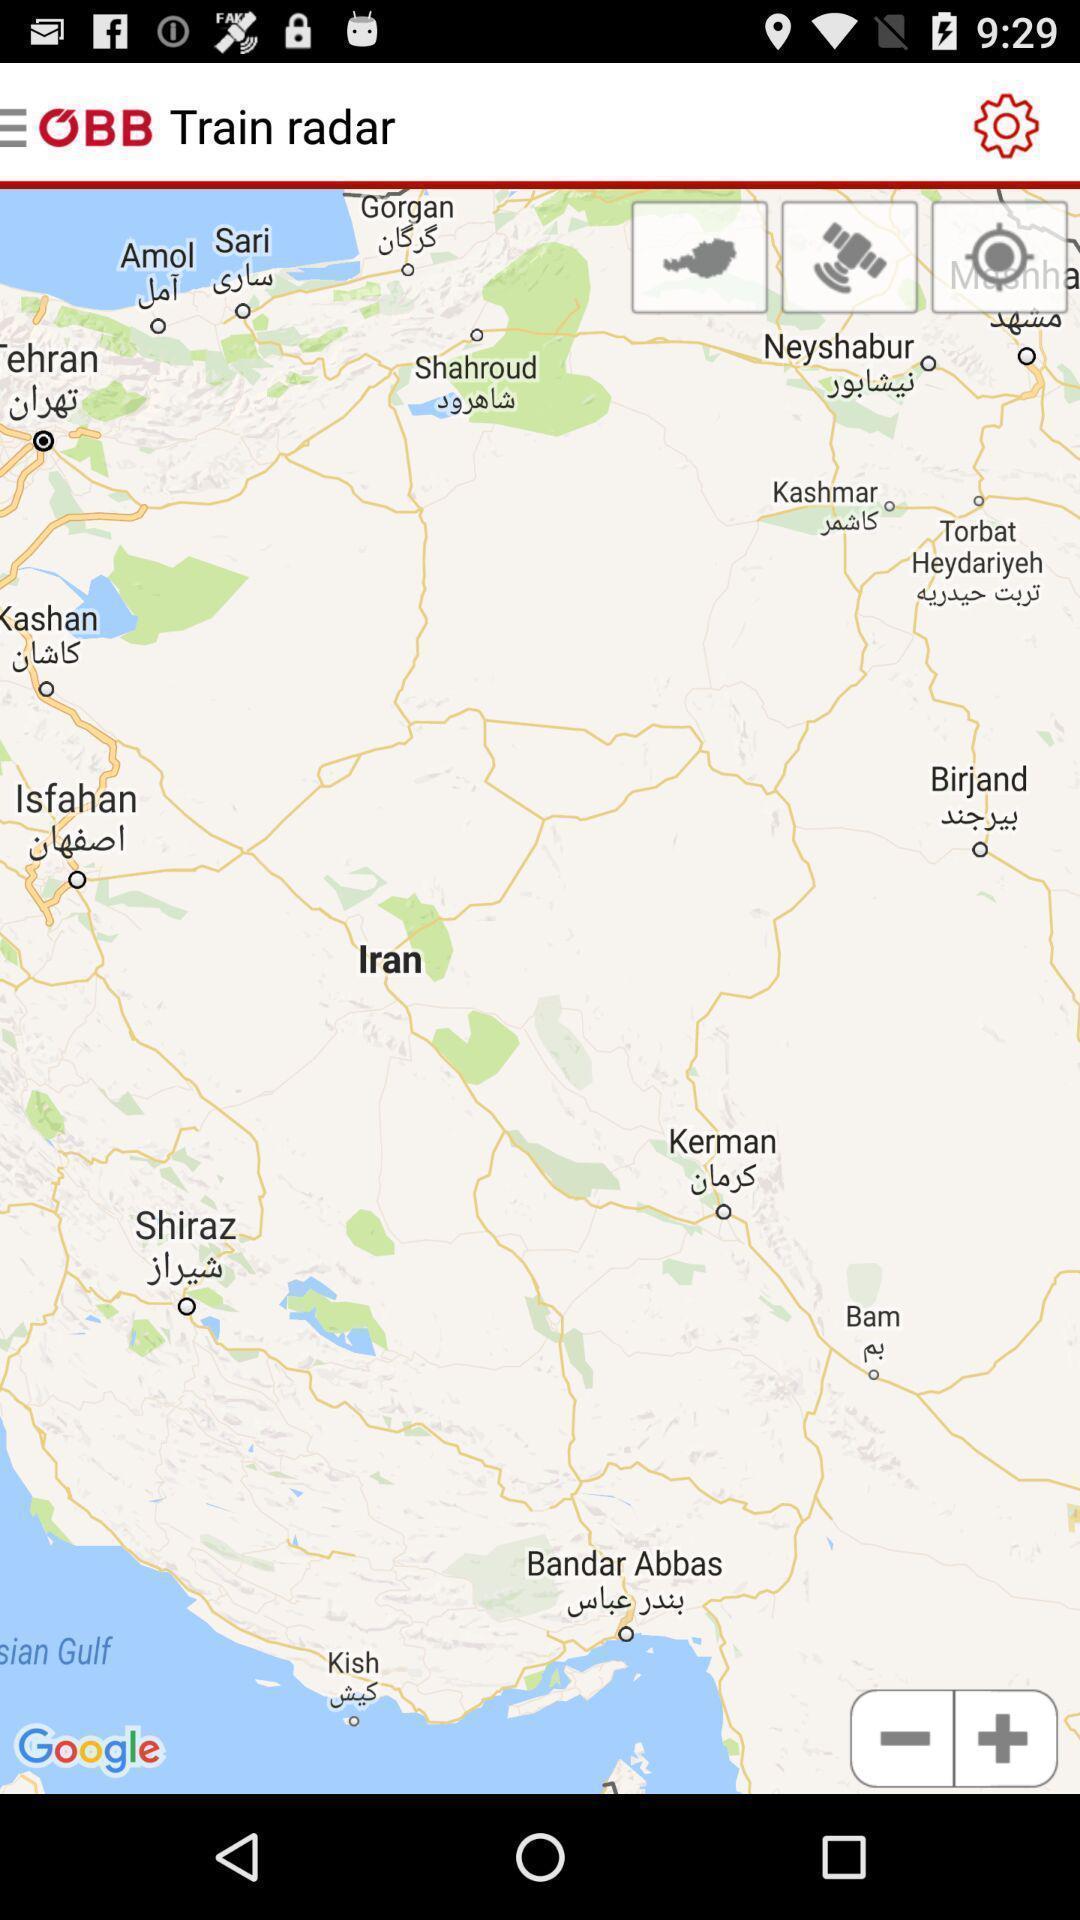Describe this image in words. Page displaying various locations. 